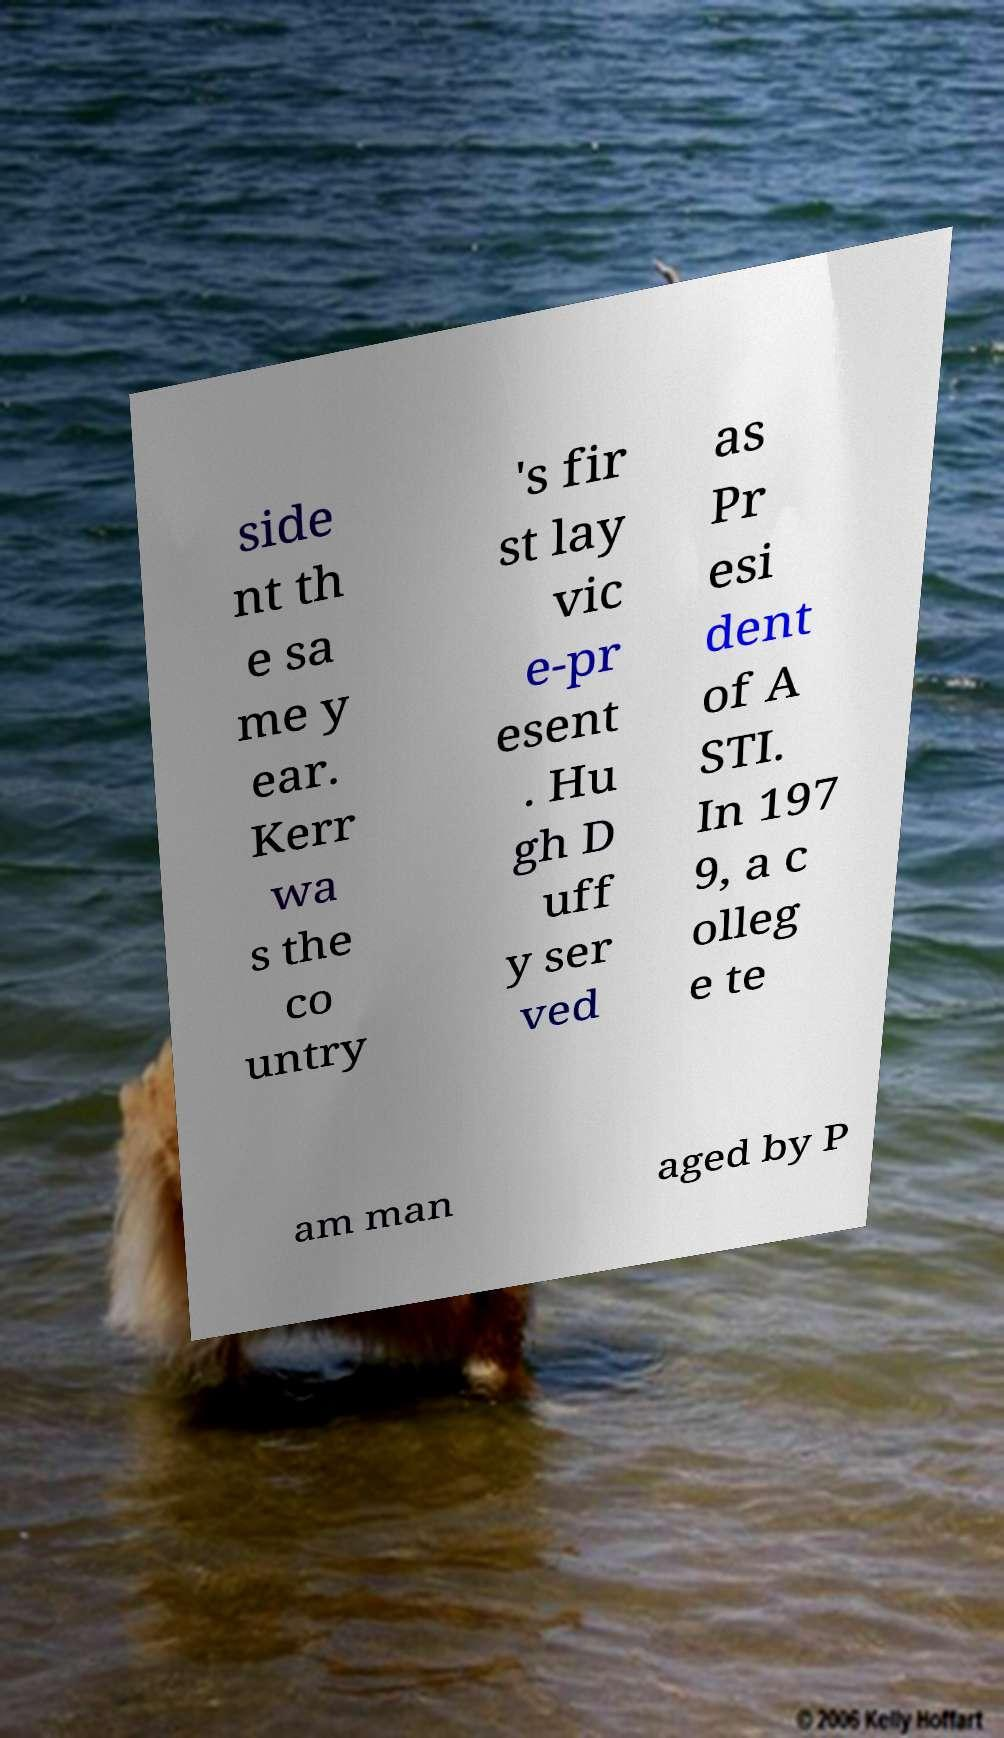There's text embedded in this image that I need extracted. Can you transcribe it verbatim? side nt th e sa me y ear. Kerr wa s the co untry 's fir st lay vic e-pr esent . Hu gh D uff y ser ved as Pr esi dent of A STI. In 197 9, a c olleg e te am man aged by P 